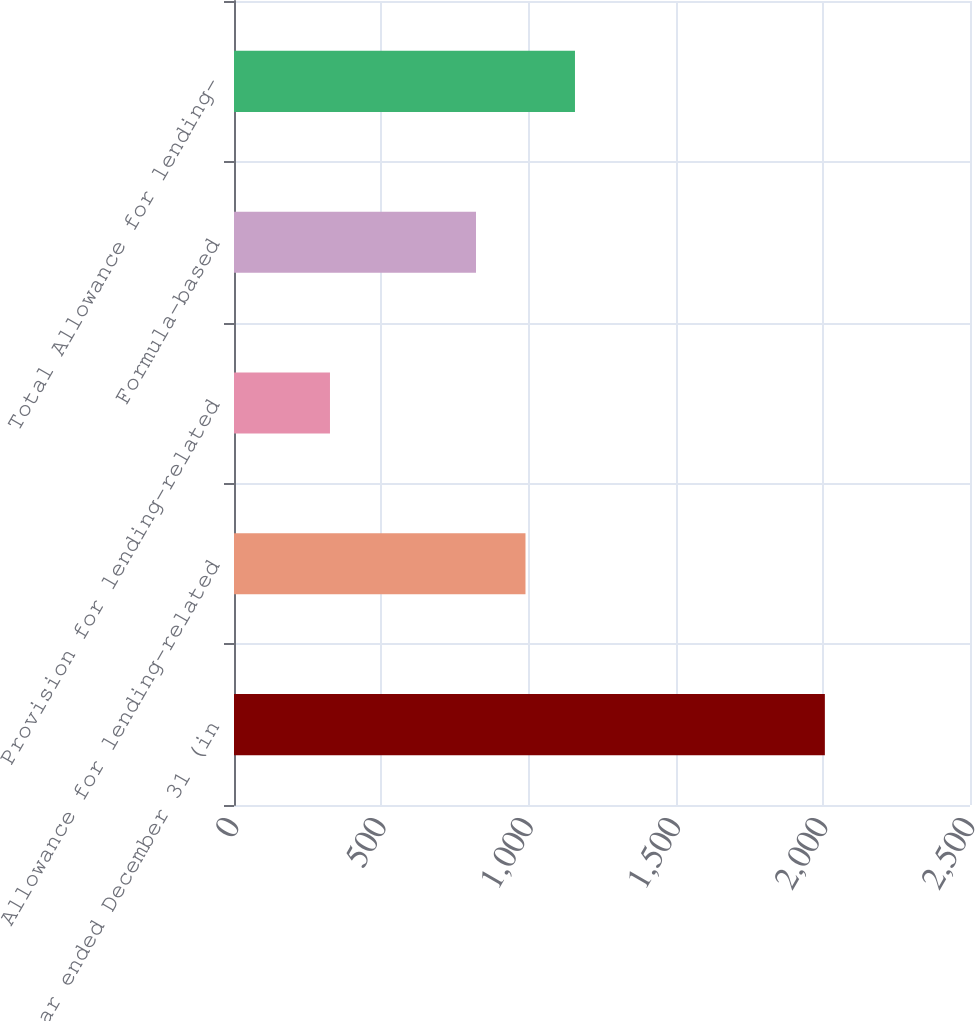Convert chart. <chart><loc_0><loc_0><loc_500><loc_500><bar_chart><fcel>Year ended December 31 (in<fcel>Allowance for lending-related<fcel>Provision for lending-related<fcel>Formula-based<fcel>Total Allowance for lending-<nl><fcel>2007<fcel>990.1<fcel>326<fcel>822<fcel>1158.2<nl></chart> 